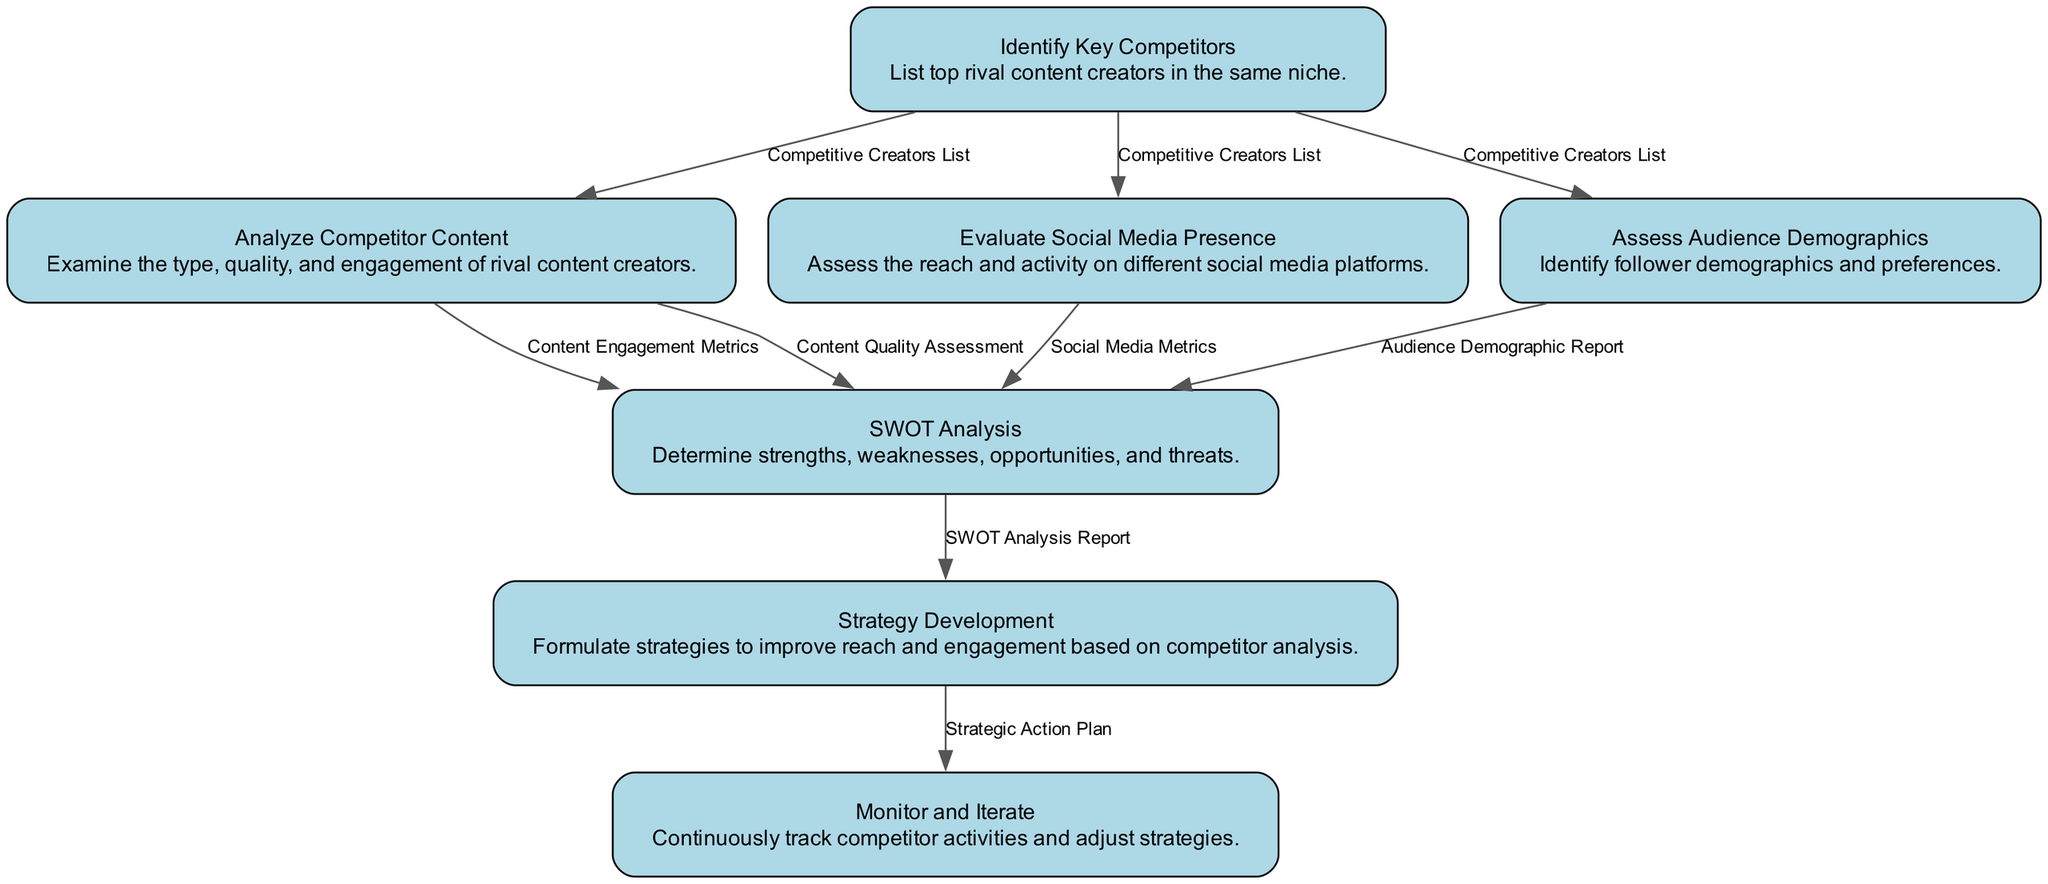What is the first step in the workflow? The first node in the diagram is "Identify Key Competitors," which serves as the starting point for the workflow by listing top rival content creators in the same niche.
Answer: Identify Key Competitors How many outputs does "Assess Audience Demographics" produce? The "Assess Audience Demographics" node produces one output, which is the "Audience Demographic Report."
Answer: 1 What are the inputs for the "SWOT Analysis" step? The inputs to the "SWOT Analysis" are the combined outputs from four other nodes: "Content Engagement Metrics," "Content Quality Assessment," "Social Media Metrics," and "Audience Demographic Report."
Answer: Content Engagement Metrics, Content Quality Assessment, Social Media Metrics, Audience Demographic Report Which step follows "Analyze Competitor Content"? The output of "Analyze Competitor Content" includes "Content Engagement Metrics" and "Content Quality Assessment," which then leads to the "SWOT Analysis" step in the workflow.
Answer: SWOT Analysis How does "Strategy Development" use its input? "Strategy Development" takes the "SWOT Analysis Report," which summarizes the strengths, weaknesses, opportunities, and threats identified, to formulate strategies to improve reach and engagement.
Answer: Formulate strategies to improve reach and engagement What is the last step of the competitor analysis workflow? The final step in the workflow is "Monitor and Iterate," which involves continuously tracking competitor activities and adjusting strategies based on performance.
Answer: Monitor and Iterate Which two nodes have "Competitive Creators List" as their input? The nodes that use "Competitive Creators List" as their input are "Analyze Competitor Content" and "Evaluate Social Media Presence," both of which assess different aspects of the competitors identified.
Answer: Analyze Competitor Content, Evaluate Social Media Presence What output is generated after "Monitor and Iterate"? The output generated after the "Monitor and Iterate" step includes both "Updated Strategy" and "Performance Metrics," which are essential for ongoing strategy adjustment.
Answer: Updated Strategy, Performance Metrics 